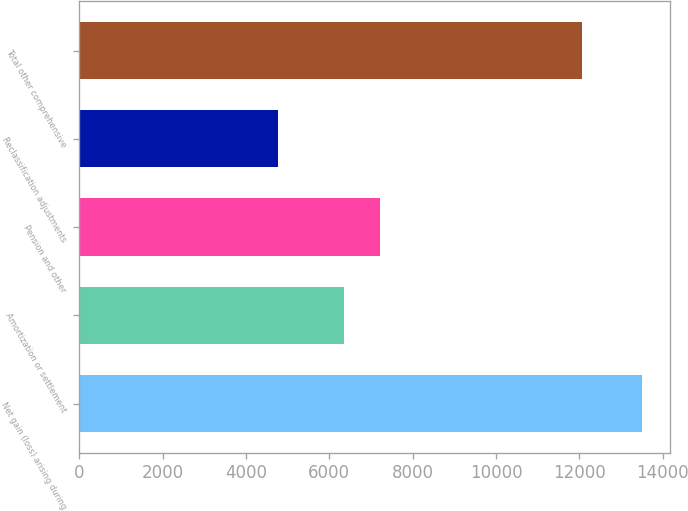<chart> <loc_0><loc_0><loc_500><loc_500><bar_chart><fcel>Net gain (loss) arising during<fcel>Amortization or settlement<fcel>Pension and other<fcel>Reclassification adjustments<fcel>Total other comprehensive<nl><fcel>13500<fcel>6341<fcel>7213<fcel>4780<fcel>12066<nl></chart> 